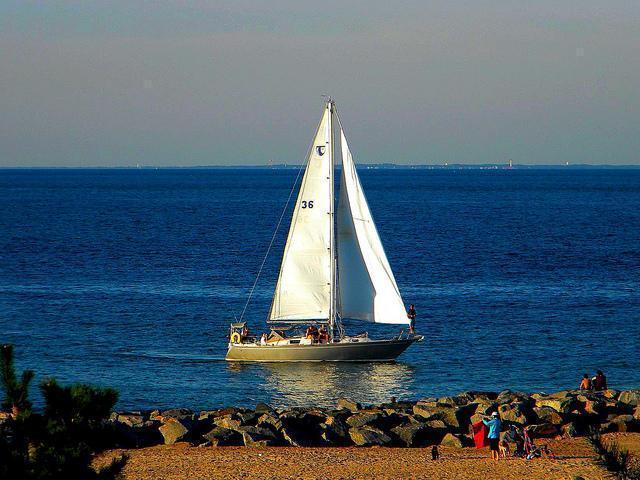How many sails are attached to the boat in the ocean?
Pick the correct solution from the four options below to address the question.
Options: Three, twentyeight, two, sixteen. Two. 